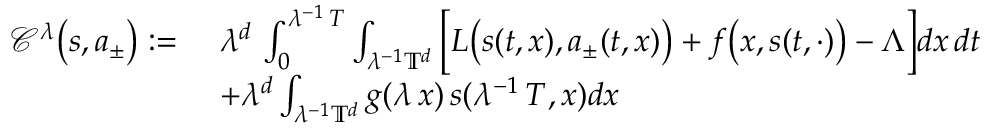Convert formula to latex. <formula><loc_0><loc_0><loc_500><loc_500>\begin{array} { r l } { \mathcal { C } ^ { \lambda } \left ( s , a _ { \pm } \right ) \colon = } & { \ \lambda ^ { d } \, \int _ { 0 } ^ { \lambda ^ { - 1 } \, T } \int _ { \lambda ^ { - 1 } \mathbb { T } ^ { d } } \left [ L \left ( s ( t , x ) , a _ { \pm } ( t , x ) \right ) + f \left ( x , s ( t , \cdot ) \right ) - \boldsymbol \Lambda \right ] d x \, d t } \\ & { \ + \lambda ^ { d } \int _ { \lambda ^ { - 1 } \mathbb { T } ^ { d } } g ( \lambda \, x ) \, s ( \lambda ^ { - 1 } \, T , x ) d x } \end{array}</formula> 